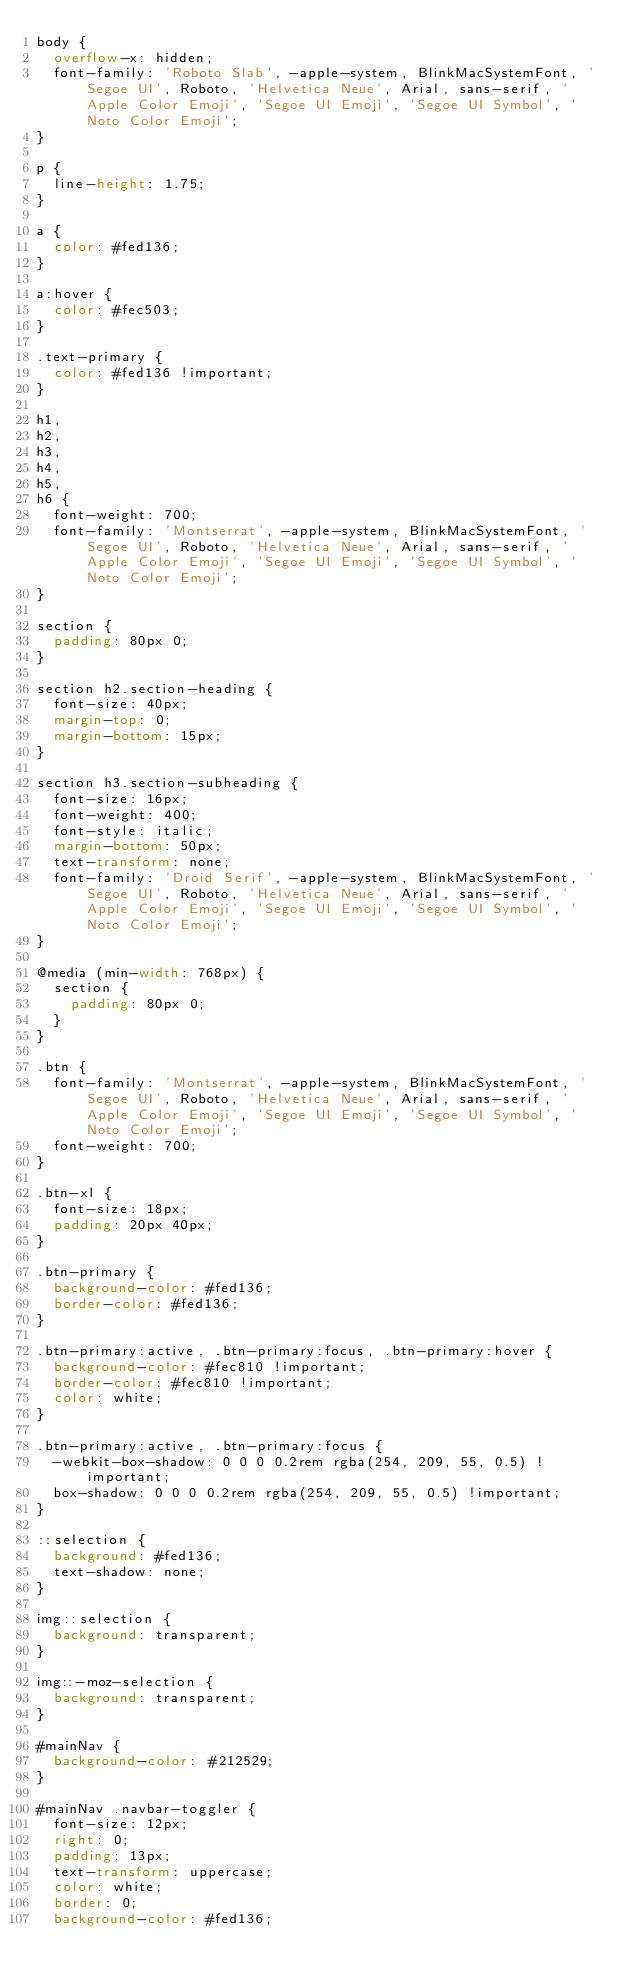Convert code to text. <code><loc_0><loc_0><loc_500><loc_500><_CSS_>body {
  overflow-x: hidden;
  font-family: 'Roboto Slab', -apple-system, BlinkMacSystemFont, 'Segoe UI', Roboto, 'Helvetica Neue', Arial, sans-serif, 'Apple Color Emoji', 'Segoe UI Emoji', 'Segoe UI Symbol', 'Noto Color Emoji';
}

p {
  line-height: 1.75;
}

a {
  color: #fed136;
}

a:hover {
  color: #fec503;
}

.text-primary {
  color: #fed136 !important;
}

h1,
h2,
h3,
h4,
h5,
h6 {
  font-weight: 700;
  font-family: 'Montserrat', -apple-system, BlinkMacSystemFont, 'Segoe UI', Roboto, 'Helvetica Neue', Arial, sans-serif, 'Apple Color Emoji', 'Segoe UI Emoji', 'Segoe UI Symbol', 'Noto Color Emoji';
}

section {
  padding: 80px 0;
}

section h2.section-heading {
  font-size: 40px;
  margin-top: 0;
  margin-bottom: 15px;
}

section h3.section-subheading {
  font-size: 16px;
  font-weight: 400;
  font-style: italic;
  margin-bottom: 50px;
  text-transform: none;
  font-family: 'Droid Serif', -apple-system, BlinkMacSystemFont, 'Segoe UI', Roboto, 'Helvetica Neue', Arial, sans-serif, 'Apple Color Emoji', 'Segoe UI Emoji', 'Segoe UI Symbol', 'Noto Color Emoji';
}

@media (min-width: 768px) {
  section {
    padding: 80px 0;
  }
}

.btn {
  font-family: 'Montserrat', -apple-system, BlinkMacSystemFont, 'Segoe UI', Roboto, 'Helvetica Neue', Arial, sans-serif, 'Apple Color Emoji', 'Segoe UI Emoji', 'Segoe UI Symbol', 'Noto Color Emoji';
  font-weight: 700;
}

.btn-xl {
  font-size: 18px;
  padding: 20px 40px;
}

.btn-primary {
  background-color: #fed136;
  border-color: #fed136;
}

.btn-primary:active, .btn-primary:focus, .btn-primary:hover {
  background-color: #fec810 !important;
  border-color: #fec810 !important;
  color: white;
}

.btn-primary:active, .btn-primary:focus {
  -webkit-box-shadow: 0 0 0 0.2rem rgba(254, 209, 55, 0.5) !important;
  box-shadow: 0 0 0 0.2rem rgba(254, 209, 55, 0.5) !important;
}

::selection {
  background: #fed136;
  text-shadow: none;
}

img::selection {
  background: transparent;
}

img::-moz-selection {
  background: transparent;
}

#mainNav {
  background-color: #212529;
}

#mainNav .navbar-toggler {
  font-size: 12px;
  right: 0;
  padding: 13px;
  text-transform: uppercase;
  color: white;
  border: 0;
  background-color: #fed136;</code> 